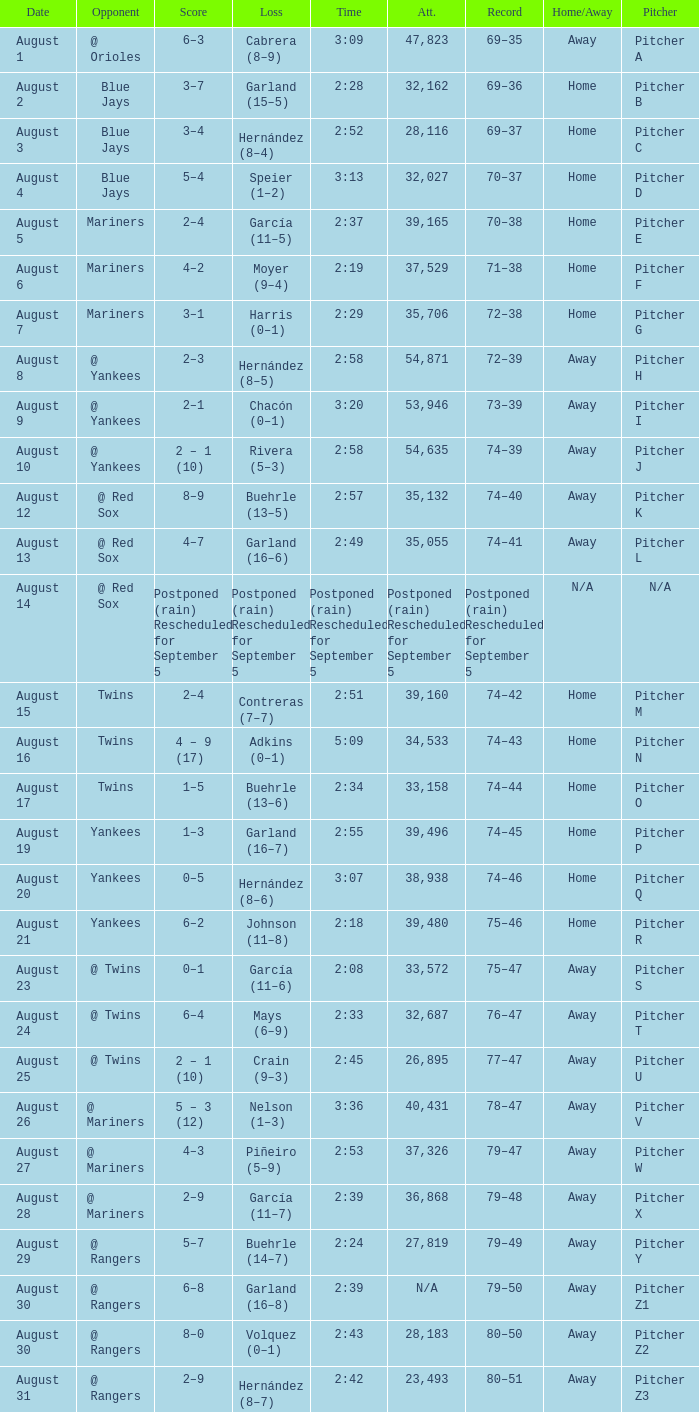Who lost with a time of 2:42? Hernández (8–7). 